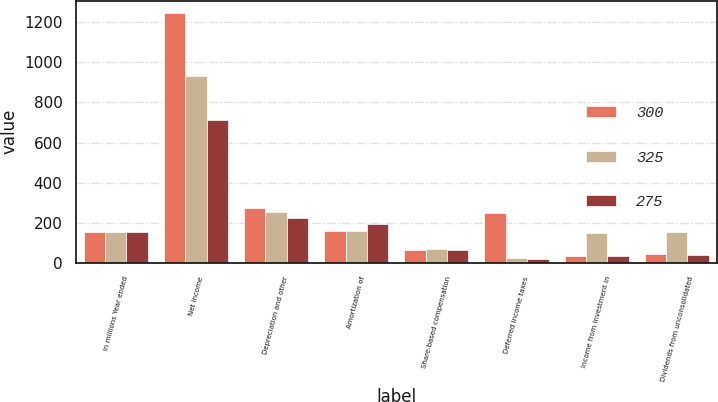<chart> <loc_0><loc_0><loc_500><loc_500><stacked_bar_chart><ecel><fcel>In millions Year ended<fcel>Net income<fcel>Depreciation and other<fcel>Amortization of<fcel>Share-based compensation<fcel>Deferred income taxes<fcel>Income from investment in<fcel>Dividends from unconsolidated<nl><fcel>300<fcel>151<fcel>1246<fcel>274<fcel>159<fcel>63<fcel>247<fcel>32<fcel>45<nl><fcel>325<fcel>151<fcel>930<fcel>253<fcel>158<fcel>68<fcel>21<fcel>147<fcel>151<nl><fcel>275<fcel>151<fcel>712<fcel>223<fcel>194<fcel>65<fcel>20<fcel>32<fcel>36<nl></chart> 